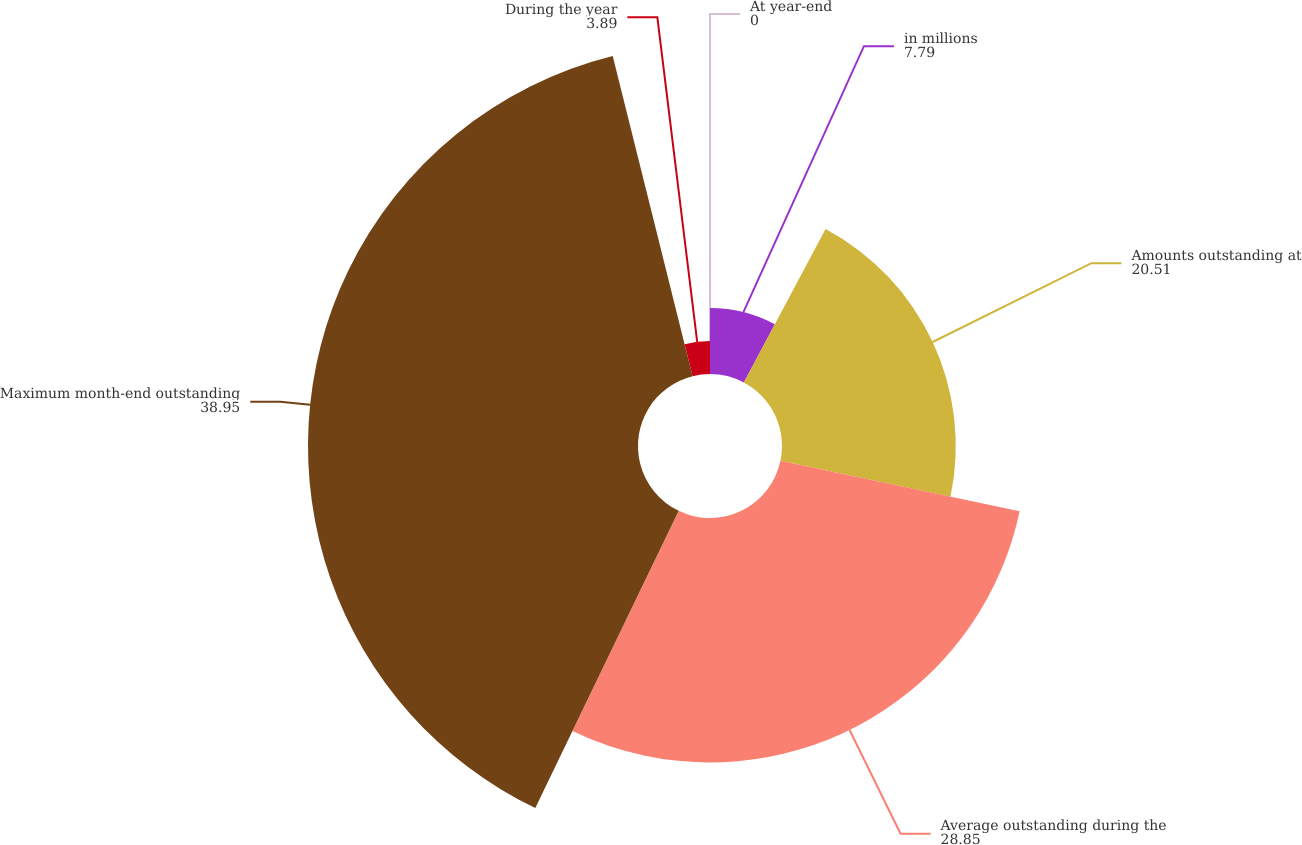Convert chart to OTSL. <chart><loc_0><loc_0><loc_500><loc_500><pie_chart><fcel>in millions<fcel>Amounts outstanding at<fcel>Average outstanding during the<fcel>Maximum month-end outstanding<fcel>During the year<fcel>At year-end<nl><fcel>7.79%<fcel>20.51%<fcel>28.85%<fcel>38.95%<fcel>3.89%<fcel>0.0%<nl></chart> 